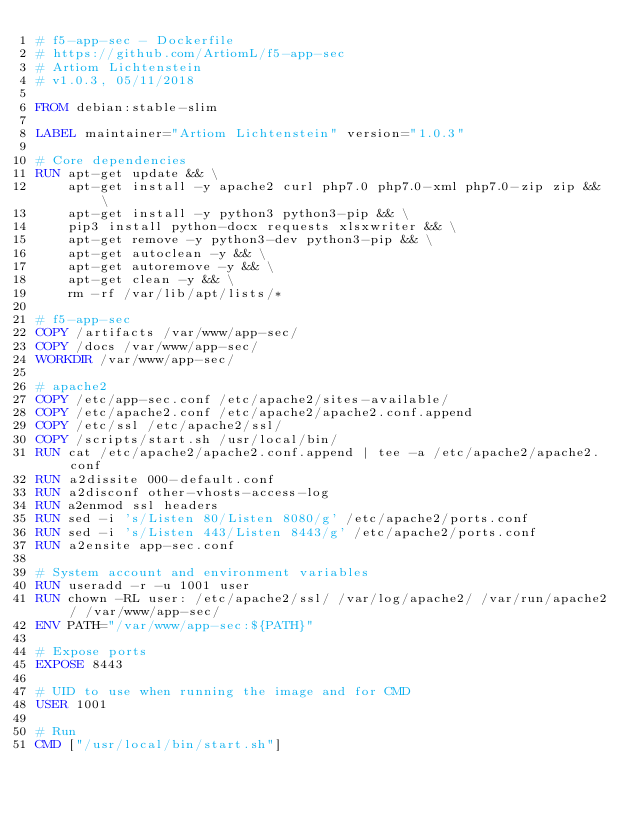<code> <loc_0><loc_0><loc_500><loc_500><_Dockerfile_># f5-app-sec - Dockerfile
# https://github.com/ArtiomL/f5-app-sec
# Artiom Lichtenstein
# v1.0.3, 05/11/2018

FROM debian:stable-slim

LABEL maintainer="Artiom Lichtenstein" version="1.0.3"

# Core dependencies
RUN apt-get update && \
	apt-get install -y apache2 curl php7.0 php7.0-xml php7.0-zip zip && \
	apt-get install -y python3 python3-pip && \
	pip3 install python-docx requests xlsxwriter && \
	apt-get remove -y python3-dev python3-pip && \
	apt-get autoclean -y && \
	apt-get autoremove -y && \
	apt-get clean -y && \
	rm -rf /var/lib/apt/lists/*

# f5-app-sec
COPY /artifacts /var/www/app-sec/
COPY /docs /var/www/app-sec/
WORKDIR /var/www/app-sec/

# apache2
COPY /etc/app-sec.conf /etc/apache2/sites-available/
COPY /etc/apache2.conf /etc/apache2/apache2.conf.append
COPY /etc/ssl /etc/apache2/ssl/
COPY /scripts/start.sh /usr/local/bin/
RUN cat /etc/apache2/apache2.conf.append | tee -a /etc/apache2/apache2.conf
RUN a2dissite 000-default.conf
RUN a2disconf other-vhosts-access-log
RUN a2enmod ssl headers
RUN sed -i 's/Listen 80/Listen 8080/g' /etc/apache2/ports.conf
RUN sed -i 's/Listen 443/Listen 8443/g' /etc/apache2/ports.conf
RUN a2ensite app-sec.conf

# System account and environment variables
RUN useradd -r -u 1001 user
RUN chown -RL user: /etc/apache2/ssl/ /var/log/apache2/ /var/run/apache2/ /var/www/app-sec/
ENV PATH="/var/www/app-sec:${PATH}"

# Expose ports
EXPOSE 8443

# UID to use when running the image and for CMD
USER 1001

# Run
CMD ["/usr/local/bin/start.sh"]
</code> 